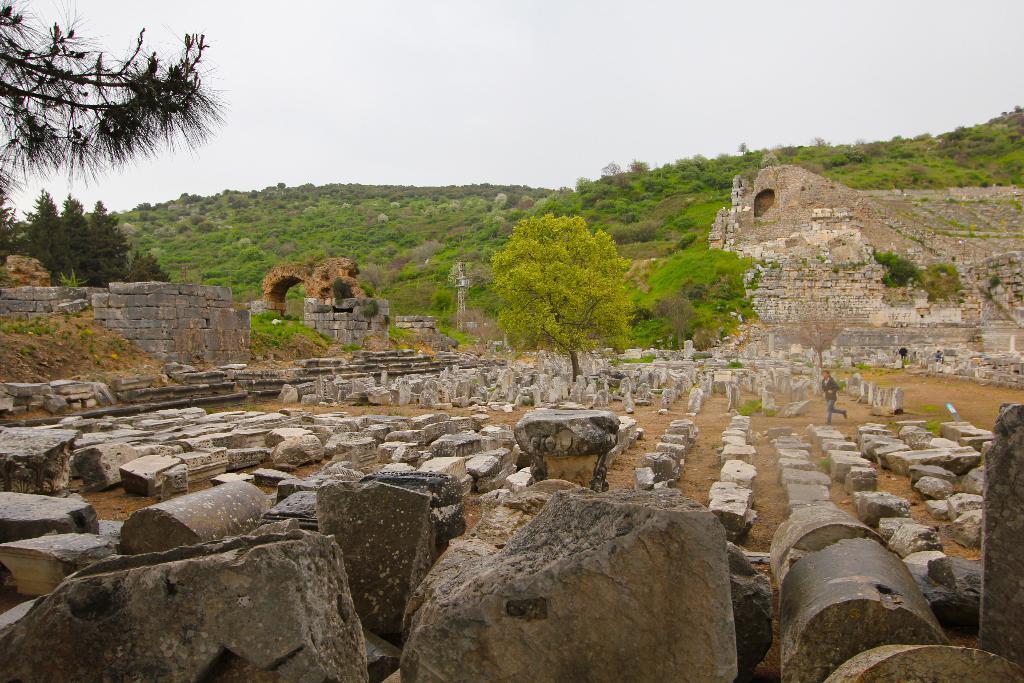Could you give a brief overview of what you see in this image? In this image I can see ground and on it I can see number of stones. I can also see a person is standing over here. In the background I can see number of trees and grass. 